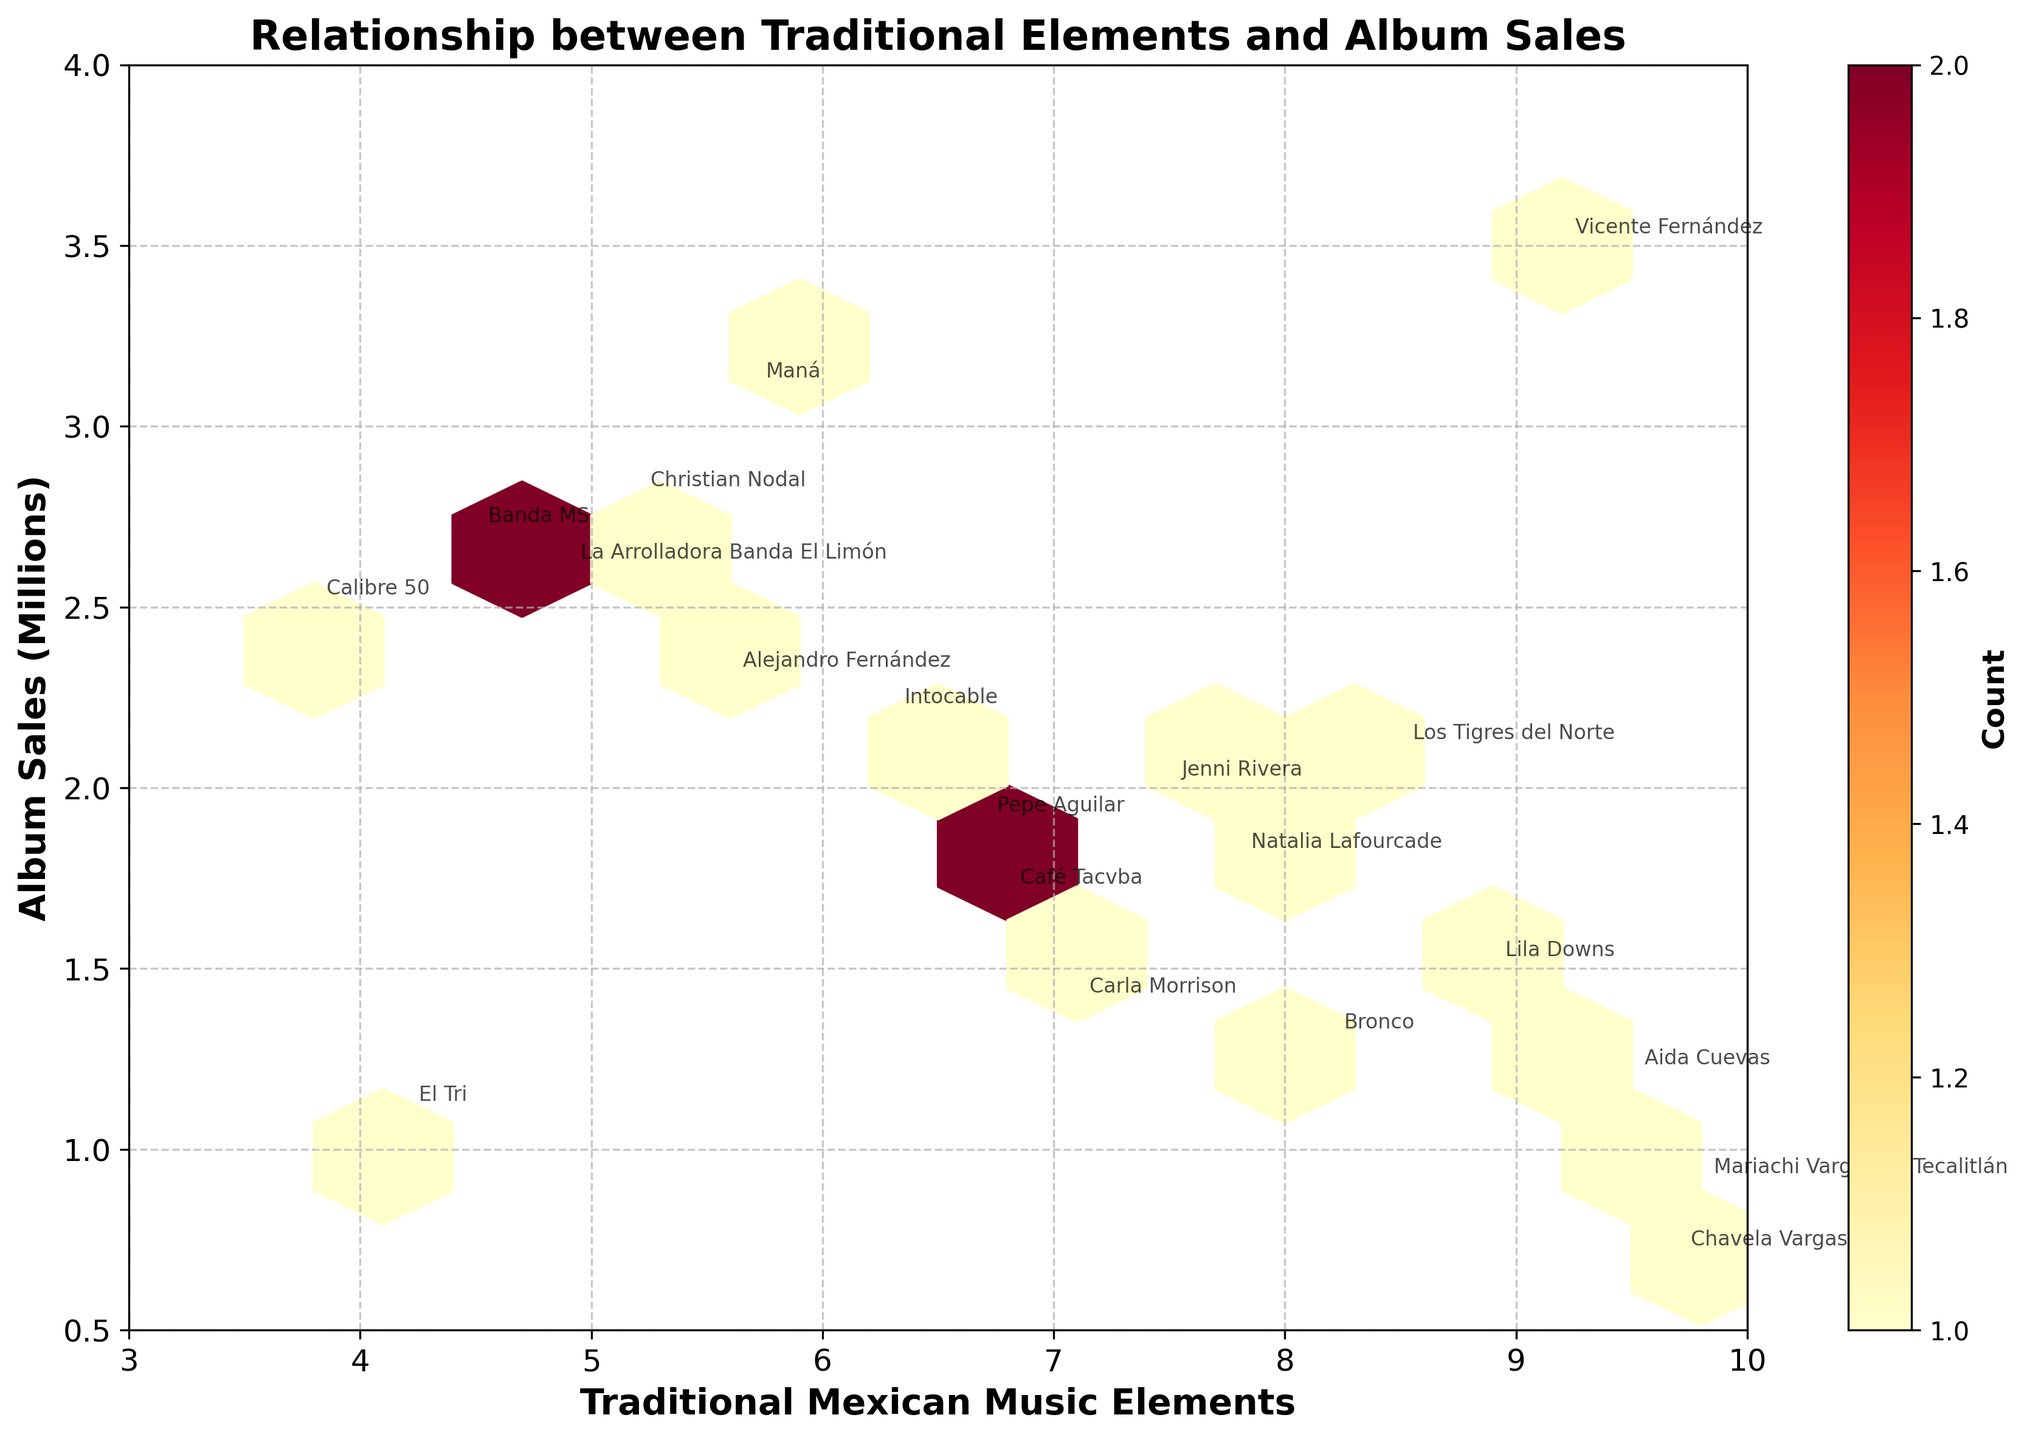What is the title of the hexbin plot? The title of the plot is usually placed at the top of the figure, clearly indicating the general topic the plot addresses.
Answer: Relationship between Traditional Elements and Album Sales What is the range of the x-axis representing Traditional Mexican Music Elements? The x-axis shows the range of values for Traditional Mexican Music Elements. The x-axis starts at 3 and ends at 10, as indicated by the axis labels and ticks.
Answer: 3 to 10 How many albums are annotated on the plot? By counting the number of annotations or labels next to the data points, we can determine the number of albums. Each annotation represents one album.
Answer: 19 Which album has the highest number of traditional elements and what are its sales? Locate the point farthest to the right on the x-axis, corresponding to the highest Traditional Mexican Music Elements, and check the sales value on the y-axis at this point. The annotation will also reveal the album name.
Answer: Mariachi Vargas de Tecalitlán - Mano a Mano, 0.9 million What is the color of the hexagons where data points are most densely packed? The color bar to the right of the plot indicates the count of data points. The densest areas correspond to hexagons with the darkest colors on the spectrum used.
Answer: Dark Red Which album has the highest sales and how many traditional elements does it incorporate? Locate the highest point on the y-axis, which represents Sales in Millions. The corresponding x-axis value and annotation near this point will indicate the number of Traditional Elements and the album name.
Answer: Vicente Fernández - Para Siempre, 9.2 Are there more albums with sales below 2 million or above 2 million? Count the hexagons below and above the 2 million mark on the y-axis to determine which area has more data points.
Answer: Below 2 million What is the median value of album sales? Arrange the sales figures of all albums in ascending order and identify the middle value(s). The dataset has an odd number of points (19), so the median is the 10th value.
Answer: 1.9 million Which two albums have the lowest number of traditional elements and what are their sales? Identify the points farthest to the left on the x-axis; check their corresponding y-axis values for sales and review their annotations.
Answer: Calibre 50 - Contigo, 2.5 million; El Tri - Ojo Por Ojo, 1.1 million 